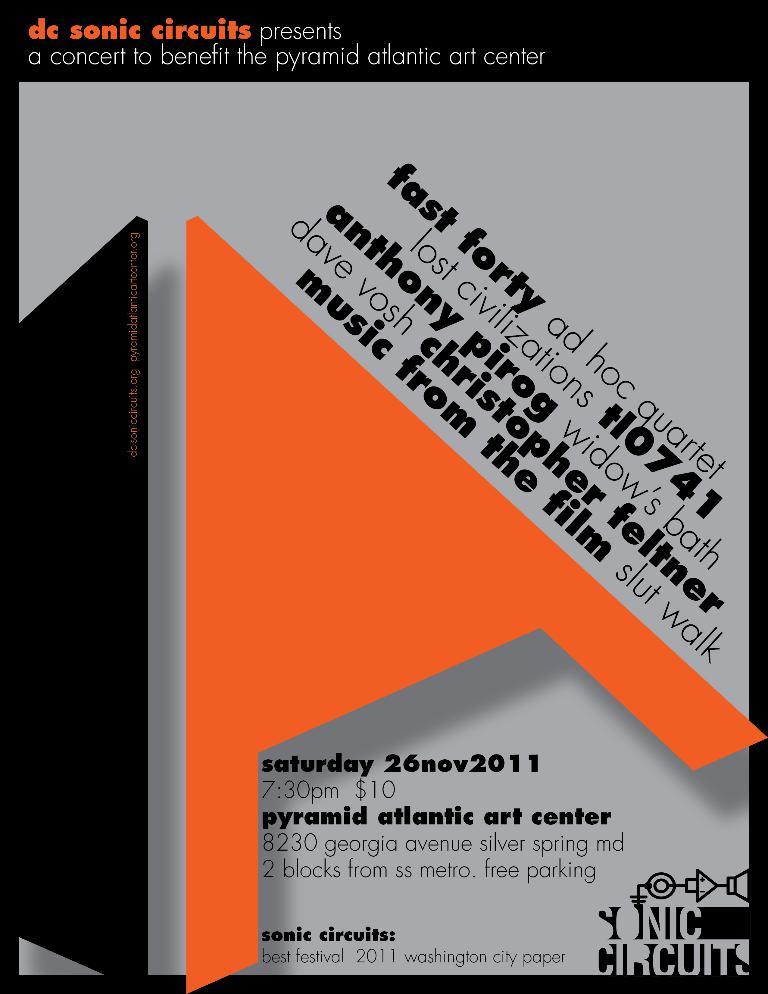How much will this event cost?
Offer a terse response. $10. 